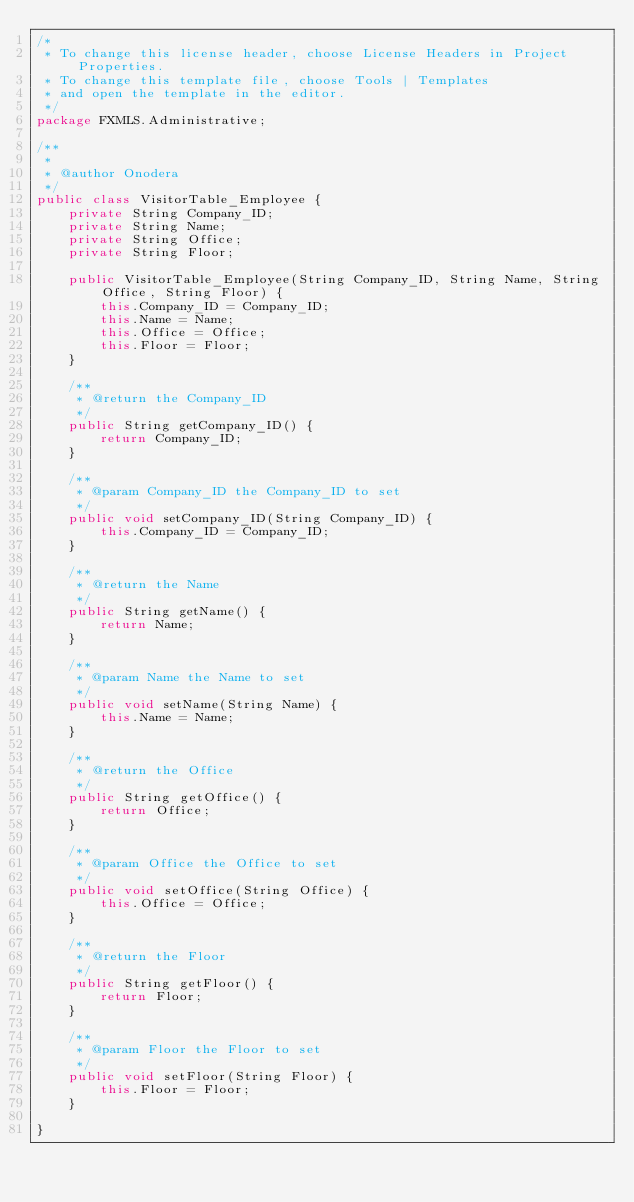<code> <loc_0><loc_0><loc_500><loc_500><_Java_>/*
 * To change this license header, choose License Headers in Project Properties.
 * To change this template file, choose Tools | Templates
 * and open the template in the editor.
 */
package FXMLS.Administrative;

/**
 *
 * @author Onodera
 */
public class VisitorTable_Employee {
    private String Company_ID;
    private String Name;
    private String Office;
    private String Floor;

    public VisitorTable_Employee(String Company_ID, String Name, String Office, String Floor) {
        this.Company_ID = Company_ID;
        this.Name = Name;
        this.Office = Office;
        this.Floor = Floor;
    }

    /**
     * @return the Company_ID
     */
    public String getCompany_ID() {
        return Company_ID;
    }

    /**
     * @param Company_ID the Company_ID to set
     */
    public void setCompany_ID(String Company_ID) {
        this.Company_ID = Company_ID;
    }

    /**
     * @return the Name
     */
    public String getName() {
        return Name;
    }

    /**
     * @param Name the Name to set
     */
    public void setName(String Name) {
        this.Name = Name;
    }

    /**
     * @return the Office
     */
    public String getOffice() {
        return Office;
    }

    /**
     * @param Office the Office to set
     */
    public void setOffice(String Office) {
        this.Office = Office;
    }

    /**
     * @return the Floor
     */
    public String getFloor() {
        return Floor;
    }

    /**
     * @param Floor the Floor to set
     */
    public void setFloor(String Floor) {
        this.Floor = Floor;
    }
    
}
</code> 